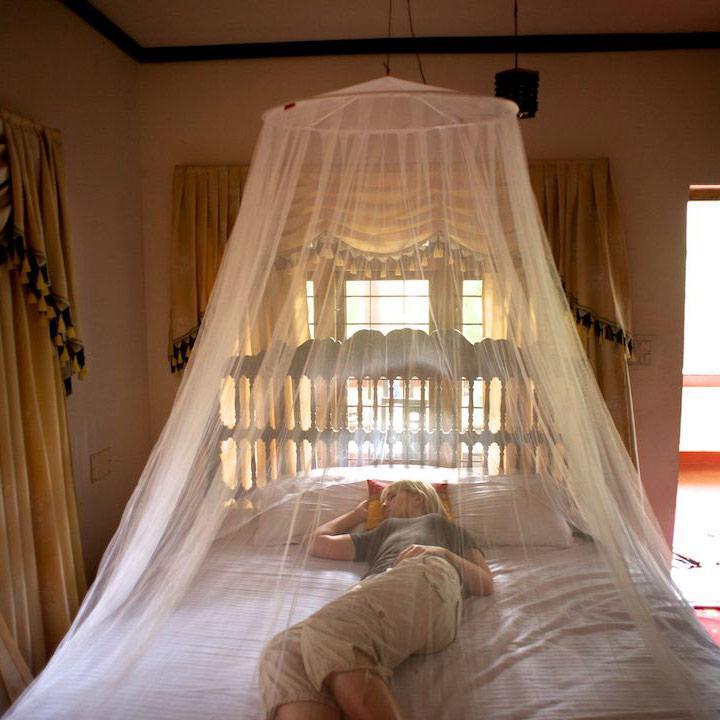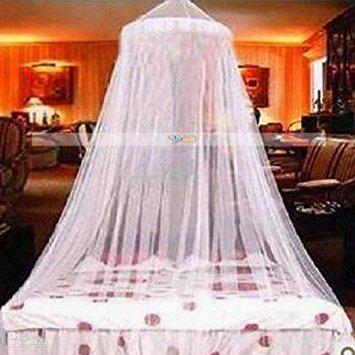The first image is the image on the left, the second image is the image on the right. For the images shown, is this caption "All images show a bed covered by a cone-shaped canopy." true? Answer yes or no. Yes. The first image is the image on the left, the second image is the image on the right. Assess this claim about the two images: "All bed nets are hanging from a central hook above the bed and draped outward.". Correct or not? Answer yes or no. Yes. 